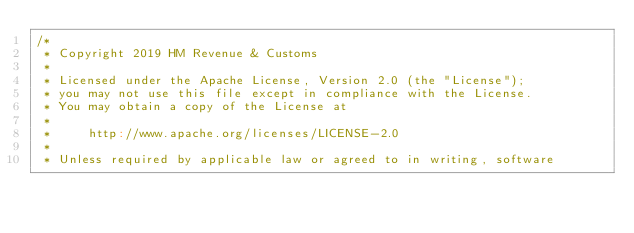Convert code to text. <code><loc_0><loc_0><loc_500><loc_500><_Scala_>/*
 * Copyright 2019 HM Revenue & Customs
 *
 * Licensed under the Apache License, Version 2.0 (the "License");
 * you may not use this file except in compliance with the License.
 * You may obtain a copy of the License at
 *
 *     http://www.apache.org/licenses/LICENSE-2.0
 *
 * Unless required by applicable law or agreed to in writing, software</code> 